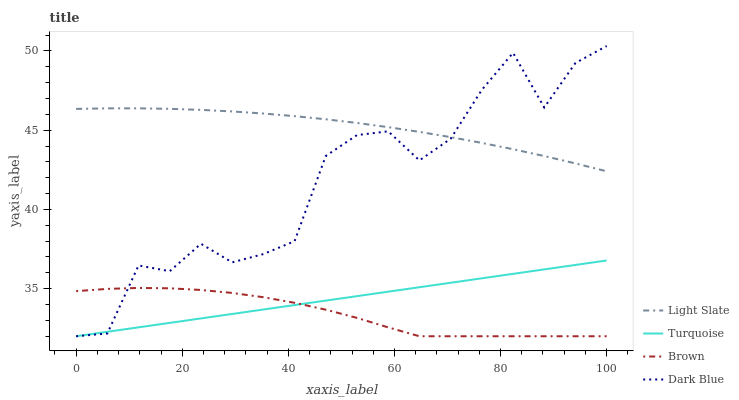Does Brown have the minimum area under the curve?
Answer yes or no. Yes. Does Light Slate have the maximum area under the curve?
Answer yes or no. Yes. Does Turquoise have the minimum area under the curve?
Answer yes or no. No. Does Turquoise have the maximum area under the curve?
Answer yes or no. No. Is Turquoise the smoothest?
Answer yes or no. Yes. Is Dark Blue the roughest?
Answer yes or no. Yes. Is Brown the smoothest?
Answer yes or no. No. Is Brown the roughest?
Answer yes or no. No. Does Turquoise have the highest value?
Answer yes or no. No. Is Turquoise less than Light Slate?
Answer yes or no. Yes. Is Light Slate greater than Turquoise?
Answer yes or no. Yes. Does Turquoise intersect Light Slate?
Answer yes or no. No. 